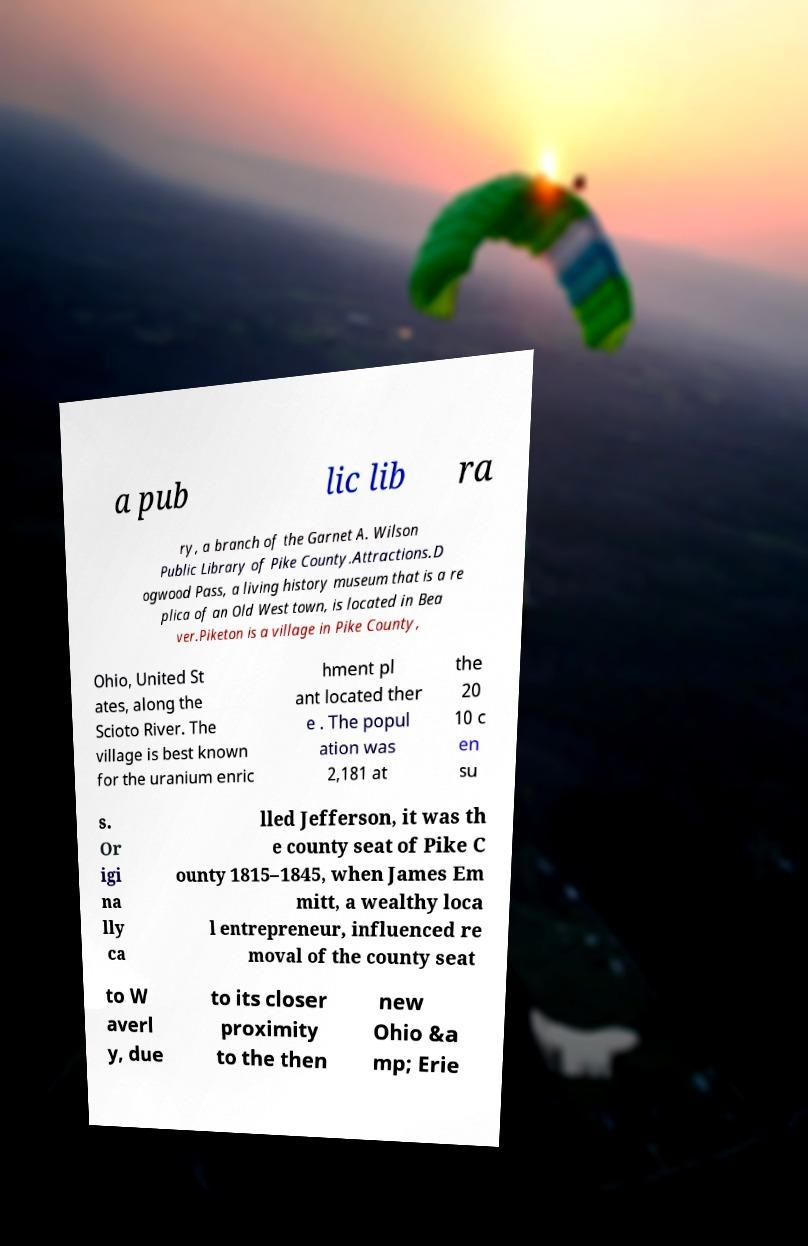Could you assist in decoding the text presented in this image and type it out clearly? a pub lic lib ra ry, a branch of the Garnet A. Wilson Public Library of Pike County.Attractions.D ogwood Pass, a living history museum that is a re plica of an Old West town, is located in Bea ver.Piketon is a village in Pike County, Ohio, United St ates, along the Scioto River. The village is best known for the uranium enric hment pl ant located ther e . The popul ation was 2,181 at the 20 10 c en su s. Or igi na lly ca lled Jefferson, it was th e county seat of Pike C ounty 1815–1845, when James Em mitt, a wealthy loca l entrepreneur, influenced re moval of the county seat to W averl y, due to its closer proximity to the then new Ohio &a mp; Erie 